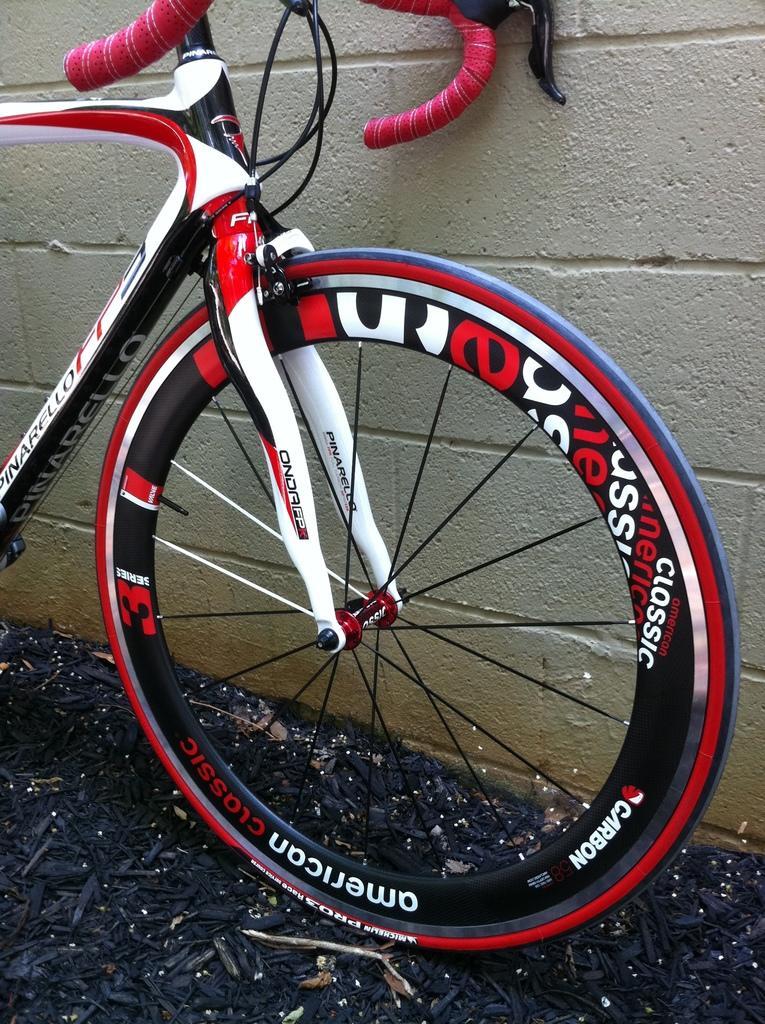Could you give a brief overview of what you see in this image? In this image we can see there is a bicycle near the wall. And at the bottom there are black color sticks. 